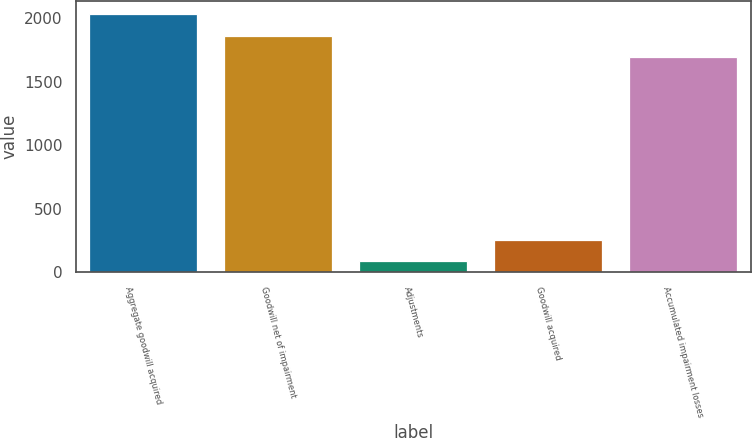<chart> <loc_0><loc_0><loc_500><loc_500><bar_chart><fcel>Aggregate goodwill acquired<fcel>Goodwill net of impairment<fcel>Adjustments<fcel>Goodwill acquired<fcel>Accumulated impairment losses<nl><fcel>2031<fcel>1861.5<fcel>84<fcel>253.5<fcel>1692<nl></chart> 